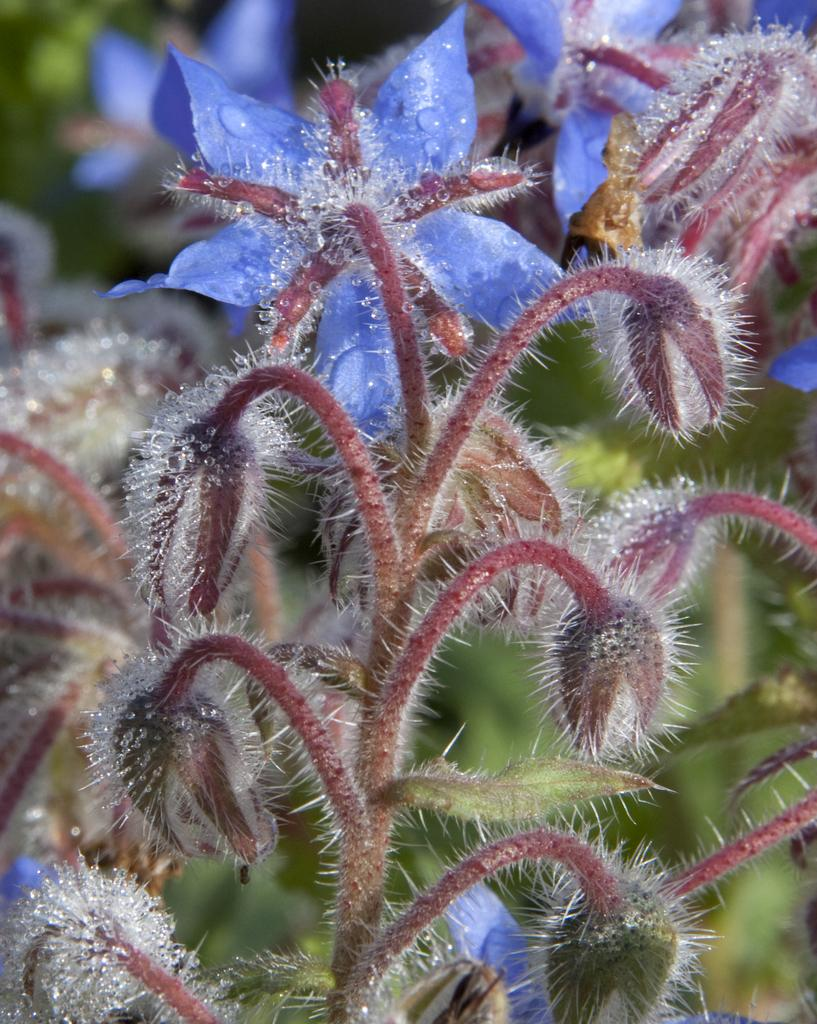What type of living organisms can be seen in the image? There are flowers in the image. Where are the flowers located? The flowers are grown on a plant. What color are the flowers in the image? The flowers are in violet color. What type of ship can be seen carrying the flowers in the image? There is no ship present in the image; the flowers are grown on a plant. What type of jar is used to store the flowers in the image? There is no jar present in the image; the flowers are still on the plant. 